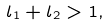<formula> <loc_0><loc_0><loc_500><loc_500>l _ { 1 } + l _ { 2 } > 1 ,</formula> 